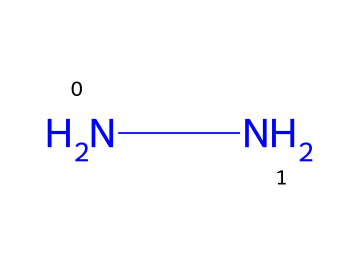How many nitrogen atoms are present in hydrazine? The SMILES representation "NN" indicates that there are two nitrogen atoms present, as each "N" corresponds to one nitrogen atom.
Answer: two What is the molecular formula of hydrazine? From the structure "NN", the molecular formula can be derived as N2H4 by adding four hydrogen atoms to balance the valence of the nitrogen atoms.
Answer: N2H4 Is hydrazine a monoatomic, diatomic, or polyatomic molecule? Since hydrazine consists of more than two atoms, specifically it has two nitrogen atoms and four hydrogen atoms, it is classified as a polyatomic molecule.
Answer: polyatomic What type of bonding is present in hydrazine? The structure shows two nitrogen atoms bonded to each other and to four hydrogen atoms, indicating covalent bonding due to the sharing of electrons.
Answer: covalent What chemical property allows hydrazine to be used in rocket fuel? The presence of nitrogen-nitrogen bonds and the ability to release a significant amount of energy upon combustion are properties that make it suitable for rocket fuel applications.
Answer: high energy release How are the two nitrogen atoms in hydrazine connected? The two nitrogen atoms in hydrazine are connected through a single bond, which is represented in the SMILES notation with no additional symbols between them.
Answer: single bond What category of chemicals does hydrazine belong to? Hydrazine is classified under the category of hydrazines, which are a specific group of organic compounds characterized by the presence of N-N bonds.
Answer: hydrazines 